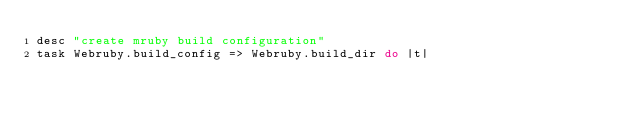<code> <loc_0><loc_0><loc_500><loc_500><_Ruby_>desc "create mruby build configuration"
task Webruby.build_config => Webruby.build_dir do |t|</code> 